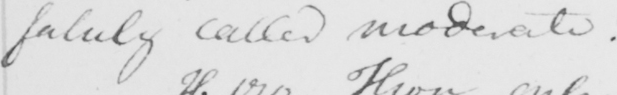Transcribe the text shown in this historical manuscript line. falsely called moderate . 